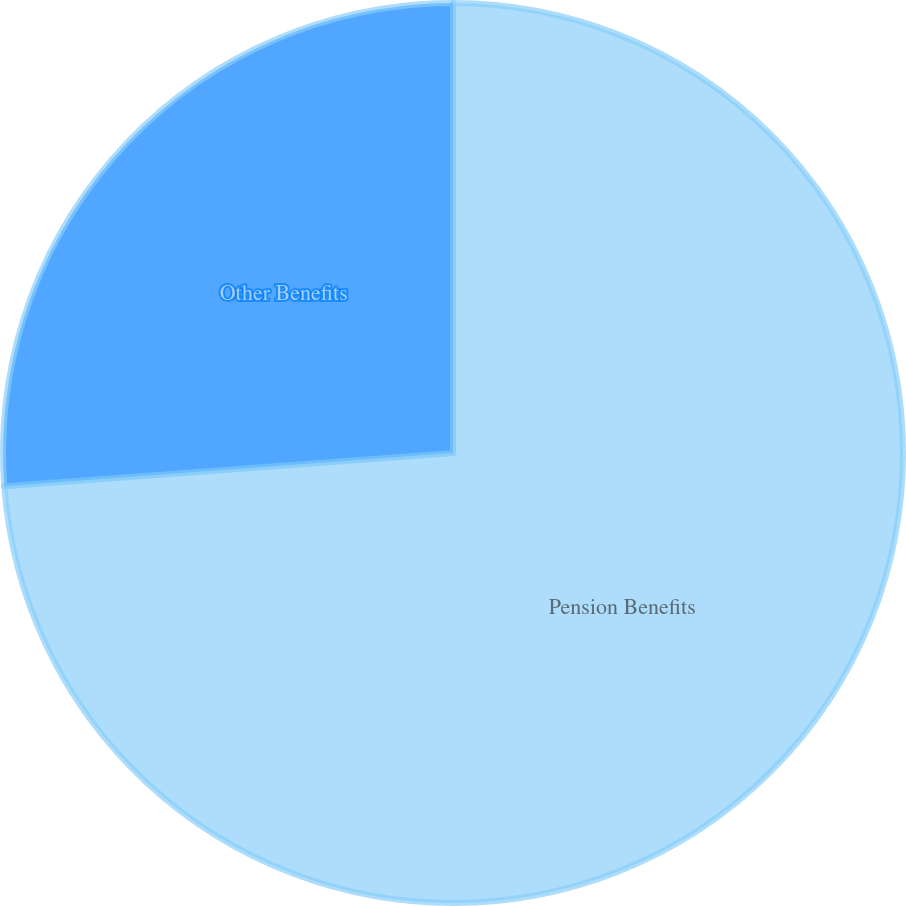Convert chart to OTSL. <chart><loc_0><loc_0><loc_500><loc_500><pie_chart><fcel>Pension Benefits<fcel>Other Benefits<nl><fcel>73.82%<fcel>26.18%<nl></chart> 